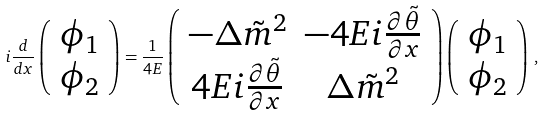<formula> <loc_0><loc_0><loc_500><loc_500>i \frac { d } { d x } \left ( \begin{array} { c } \phi _ { 1 } \\ \phi _ { 2 } \end{array} \right ) = \frac { 1 } { 4 E } \left ( \begin{array} { c c } - \Delta \tilde { m } ^ { 2 } & - 4 E i \frac { \partial \tilde { \theta } } { \partial x } \\ 4 E i \frac { \partial \tilde { \theta } } { \partial x } & \Delta \tilde { m } ^ { 2 } \end{array} \right ) \left ( \begin{array} { c } \phi _ { 1 } \\ \phi _ { 2 } \end{array} \right ) \, ,</formula> 